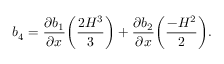<formula> <loc_0><loc_0><loc_500><loc_500>b _ { 4 } = \frac { \partial b _ { 1 } } { \partial x } \left ( \frac { 2 H ^ { 3 } } { 3 } \right ) + \frac { \partial b _ { 2 } } { \partial x } \left ( \frac { - H ^ { 2 } } { 2 } \right ) .</formula> 